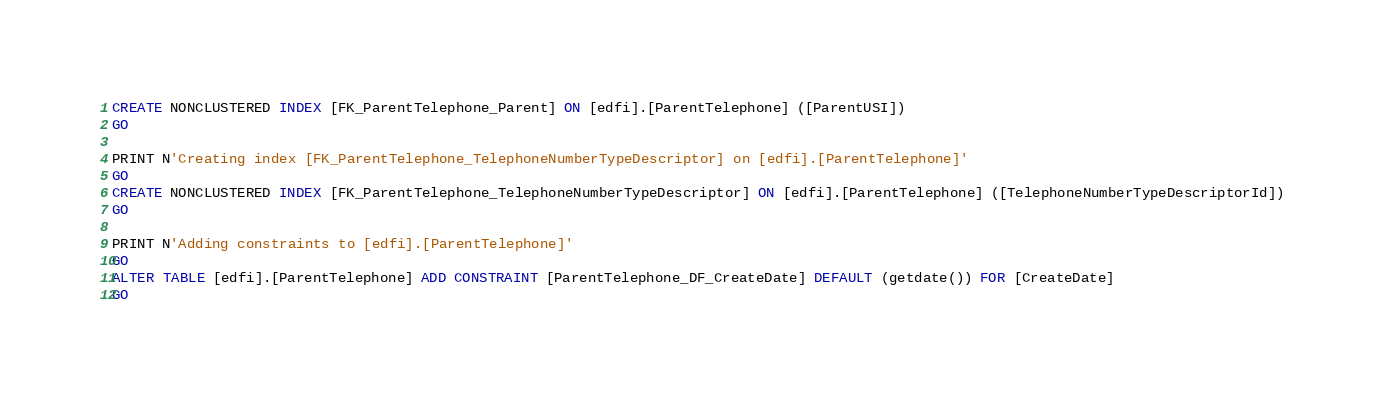Convert code to text. <code><loc_0><loc_0><loc_500><loc_500><_SQL_>CREATE NONCLUSTERED INDEX [FK_ParentTelephone_Parent] ON [edfi].[ParentTelephone] ([ParentUSI])
GO

PRINT N'Creating index [FK_ParentTelephone_TelephoneNumberTypeDescriptor] on [edfi].[ParentTelephone]'
GO
CREATE NONCLUSTERED INDEX [FK_ParentTelephone_TelephoneNumberTypeDescriptor] ON [edfi].[ParentTelephone] ([TelephoneNumberTypeDescriptorId])
GO

PRINT N'Adding constraints to [edfi].[ParentTelephone]'
GO
ALTER TABLE [edfi].[ParentTelephone] ADD CONSTRAINT [ParentTelephone_DF_CreateDate] DEFAULT (getdate()) FOR [CreateDate]
GO
</code> 